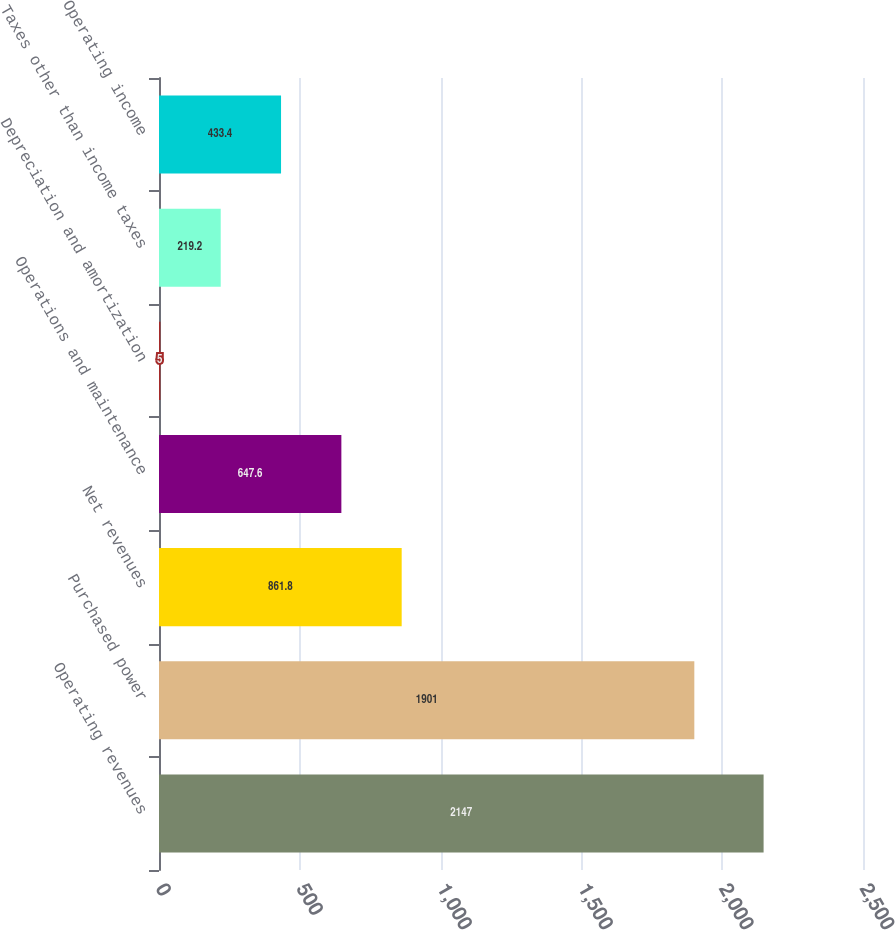<chart> <loc_0><loc_0><loc_500><loc_500><bar_chart><fcel>Operating revenues<fcel>Purchased power<fcel>Net revenues<fcel>Operations and maintenance<fcel>Depreciation and amortization<fcel>Taxes other than income taxes<fcel>Operating income<nl><fcel>2147<fcel>1901<fcel>861.8<fcel>647.6<fcel>5<fcel>219.2<fcel>433.4<nl></chart> 